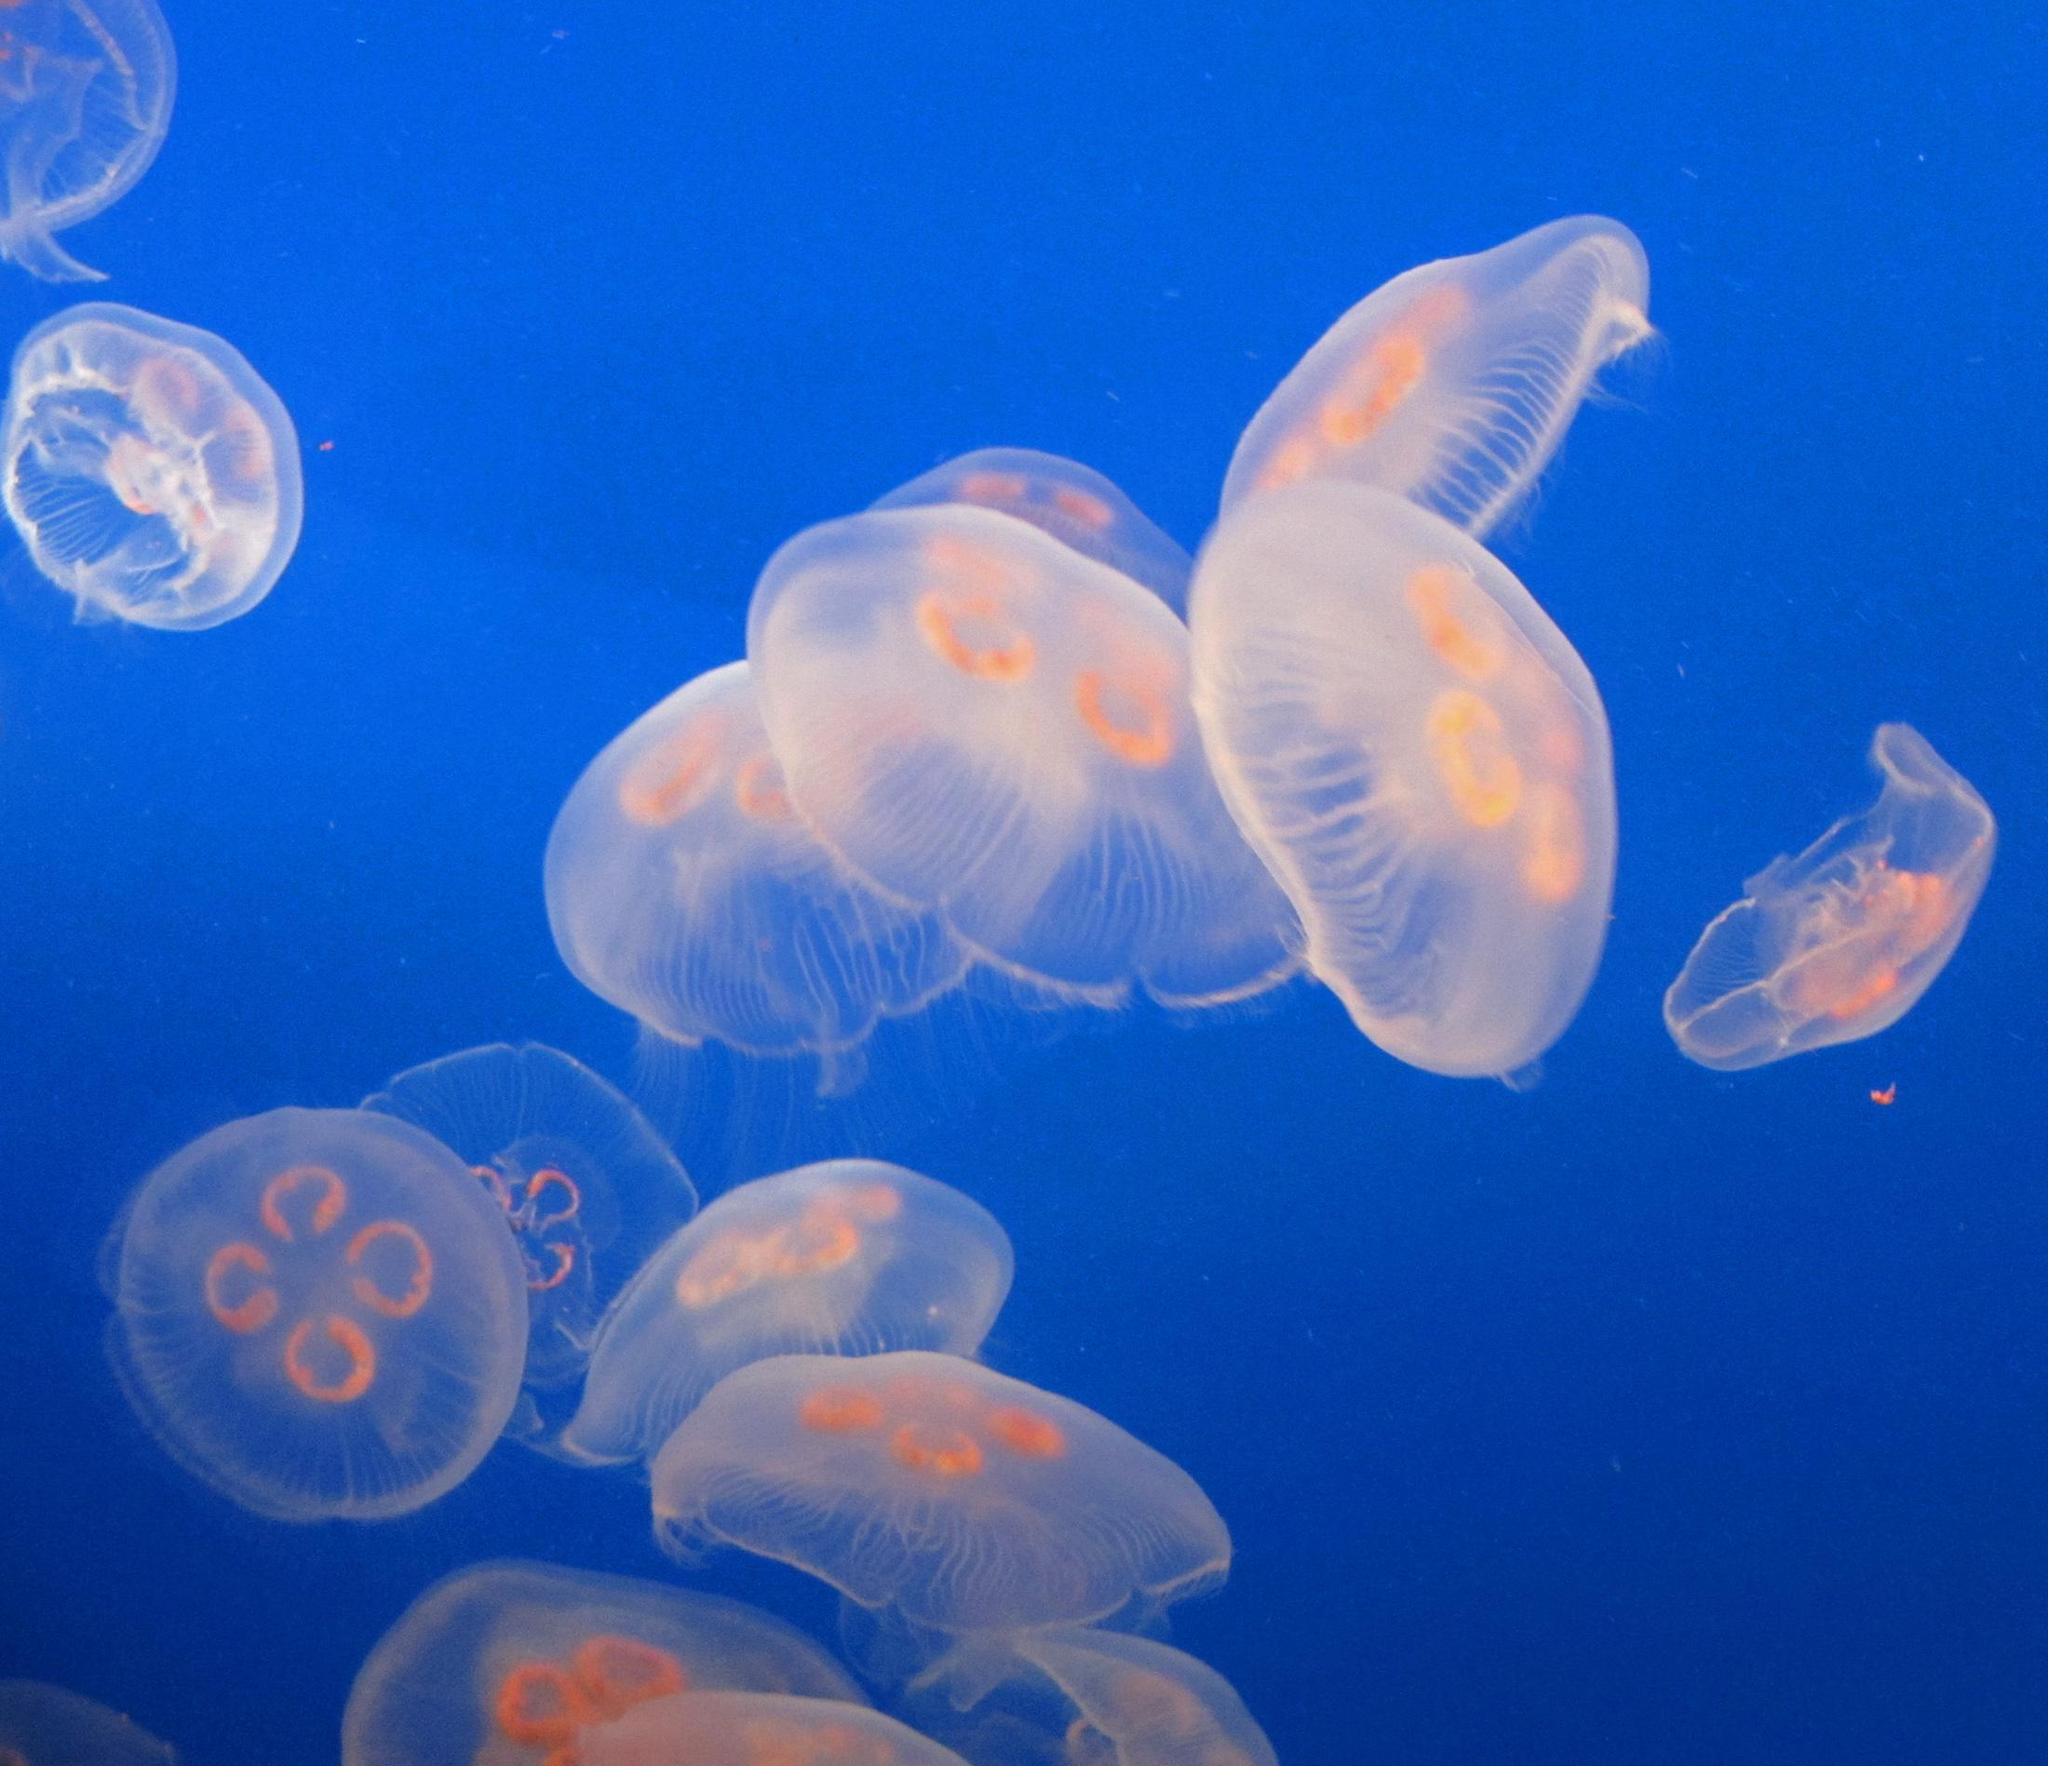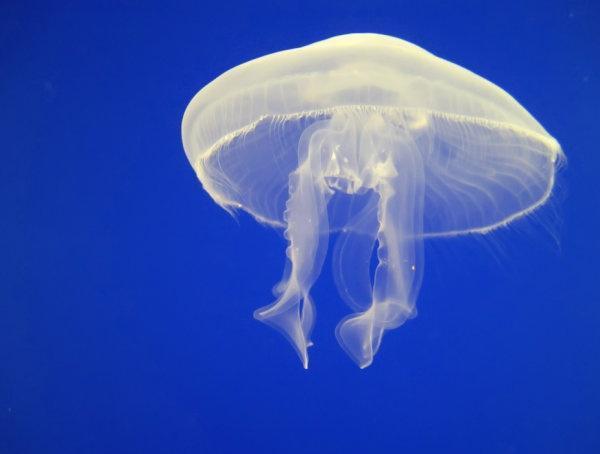The first image is the image on the left, the second image is the image on the right. Analyze the images presented: Is the assertion "there is only one jellyfish on one of the images" valid? Answer yes or no. Yes. 